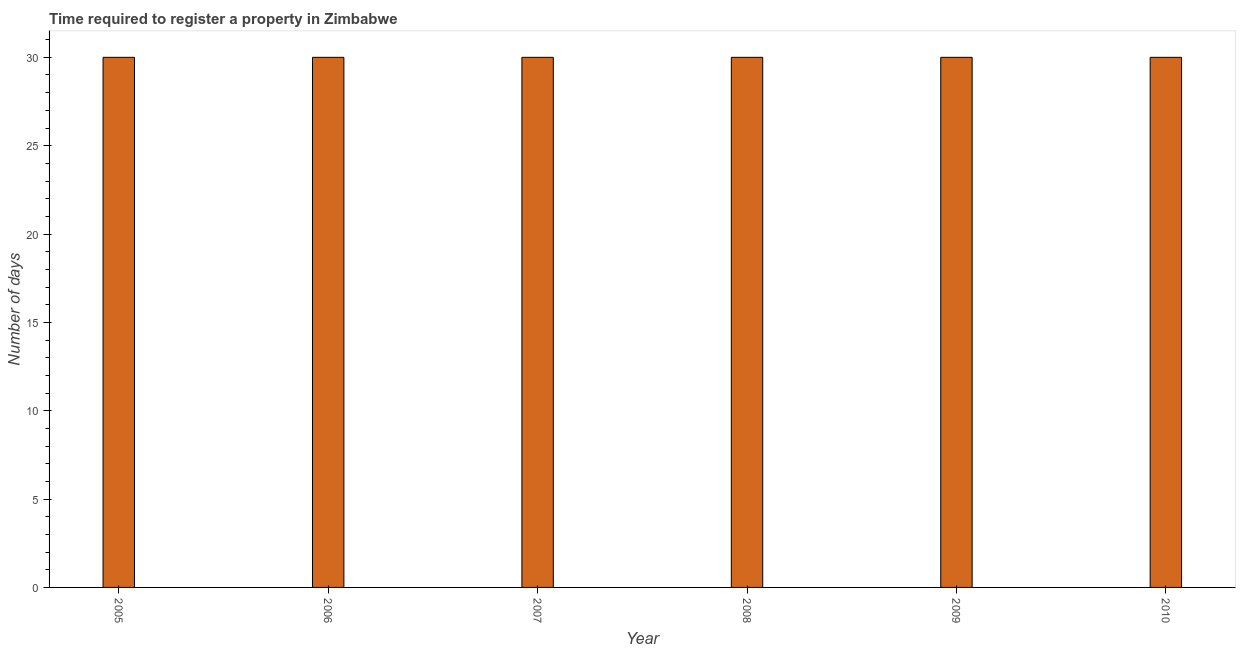Does the graph contain grids?
Your response must be concise. No. What is the title of the graph?
Offer a very short reply. Time required to register a property in Zimbabwe. What is the label or title of the Y-axis?
Your answer should be very brief. Number of days. What is the number of days required to register property in 2005?
Your answer should be very brief. 30. Across all years, what is the maximum number of days required to register property?
Offer a terse response. 30. What is the sum of the number of days required to register property?
Offer a very short reply. 180. What is the median number of days required to register property?
Your response must be concise. 30. In how many years, is the number of days required to register property greater than 7 days?
Your response must be concise. 6. Do a majority of the years between 2010 and 2005 (inclusive) have number of days required to register property greater than 14 days?
Offer a very short reply. Yes. Is the difference between the number of days required to register property in 2006 and 2007 greater than the difference between any two years?
Provide a short and direct response. Yes. What is the difference between the highest and the second highest number of days required to register property?
Make the answer very short. 0. Is the sum of the number of days required to register property in 2007 and 2008 greater than the maximum number of days required to register property across all years?
Make the answer very short. Yes. How many bars are there?
Make the answer very short. 6. Are all the bars in the graph horizontal?
Give a very brief answer. No. How many years are there in the graph?
Your response must be concise. 6. What is the difference between two consecutive major ticks on the Y-axis?
Your answer should be very brief. 5. Are the values on the major ticks of Y-axis written in scientific E-notation?
Offer a very short reply. No. What is the Number of days of 2005?
Provide a succinct answer. 30. What is the Number of days in 2008?
Give a very brief answer. 30. What is the difference between the Number of days in 2005 and 2006?
Keep it short and to the point. 0. What is the difference between the Number of days in 2005 and 2007?
Provide a short and direct response. 0. What is the difference between the Number of days in 2005 and 2008?
Your response must be concise. 0. What is the difference between the Number of days in 2005 and 2009?
Your answer should be very brief. 0. What is the difference between the Number of days in 2005 and 2010?
Provide a succinct answer. 0. What is the difference between the Number of days in 2006 and 2007?
Make the answer very short. 0. What is the difference between the Number of days in 2006 and 2008?
Ensure brevity in your answer.  0. What is the difference between the Number of days in 2006 and 2010?
Your answer should be compact. 0. What is the difference between the Number of days in 2007 and 2008?
Give a very brief answer. 0. What is the difference between the Number of days in 2007 and 2009?
Make the answer very short. 0. What is the difference between the Number of days in 2009 and 2010?
Provide a short and direct response. 0. What is the ratio of the Number of days in 2005 to that in 2007?
Your response must be concise. 1. What is the ratio of the Number of days in 2005 to that in 2008?
Your response must be concise. 1. What is the ratio of the Number of days in 2005 to that in 2009?
Provide a short and direct response. 1. What is the ratio of the Number of days in 2006 to that in 2007?
Offer a very short reply. 1. What is the ratio of the Number of days in 2006 to that in 2009?
Provide a succinct answer. 1. What is the ratio of the Number of days in 2006 to that in 2010?
Give a very brief answer. 1. What is the ratio of the Number of days in 2007 to that in 2008?
Make the answer very short. 1. What is the ratio of the Number of days in 2007 to that in 2009?
Your response must be concise. 1. What is the ratio of the Number of days in 2009 to that in 2010?
Offer a very short reply. 1. 